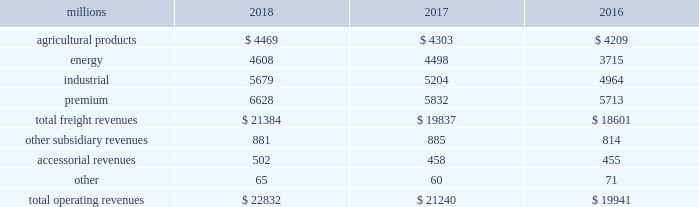Notes to the consolidated financial statements union pacific corporation and subsidiary companies for purposes of this report , unless the context otherwise requires , all references herein to the 201ccorporation 201d , 201ccompany 201d , 201cupc 201d , 201cwe 201d , 201cus 201d , and 201cour 201d mean union pacific corporation and its subsidiaries , including union pacific railroad company , which will be separately referred to herein as 201cuprr 201d or the 201crailroad 201d .
Nature of operations operations and segmentation 2013 we are a class i railroad operating in the u.s .
Our network includes 32236 route miles , linking pacific coast and gulf coast ports with the midwest and eastern u.s .
Gateways and providing several corridors to key mexican gateways .
We own 26039 miles and operate on the remainder pursuant to trackage rights or leases .
We serve the western two-thirds of the country and maintain coordinated schedules with other rail carriers for the handling of freight to and from the atlantic coast , the pacific coast , the southeast , the southwest , canada , and mexico .
Export and import traffic is moved through gulf coast and pacific coast ports and across the mexican and canadian borders .
The railroad , along with its subsidiaries and rail affiliates , is our one reportable operating segment .
Although we provide and analyze revenue by commodity group , we treat the financial results of the railroad as one segment due to the integrated nature of our rail network .
Our operating revenues are primarily derived from contracts with customers for the transportation of freight from origin to destination .
Effective january 1 , 2018 , the company reclassified its six commodity groups into four : agricultural products , energy , industrial , and premium .
The table represents a disaggregation of our freight and other revenues: .
Although our revenues are principally derived from customers domiciled in the u.s. , the ultimate points of origination or destination for some products we transport are outside the u.s .
Each of our commodity groups includes revenue from shipments to and from mexico .
Included in the above table are freight revenues from our mexico business which amounted to $ 2.5 billion in 2018 , $ 2.3 billion in 2017 , and $ 2.2 billion in 2016 .
Basis of presentation 2013 the consolidated financial statements are presented in accordance with accounting principles generally accepted in the u.s .
( gaap ) as codified in the financial accounting standards board ( fasb ) accounting standards codification ( asc ) .
Significant accounting policies principles of consolidation 2013 the consolidated financial statements include the accounts of union pacific corporation and all of its subsidiaries .
Investments in affiliated companies ( 20% ( 20 % ) to 50% ( 50 % ) owned ) are accounted for using the equity method of accounting .
All intercompany transactions are eliminated .
We currently have no less than majority-owned investments that require consolidation under variable interest entity requirements .
Cash , cash equivalents and restricted cash 2013 cash equivalents consist of investments with original maturities of three months or less .
Amounts included in restricted cash represent those required to be set aside by contractual agreement. .
What percent of total operating revenues in 2018 were industrial? 
Computations: (5679 / 22832)
Answer: 0.24873. 